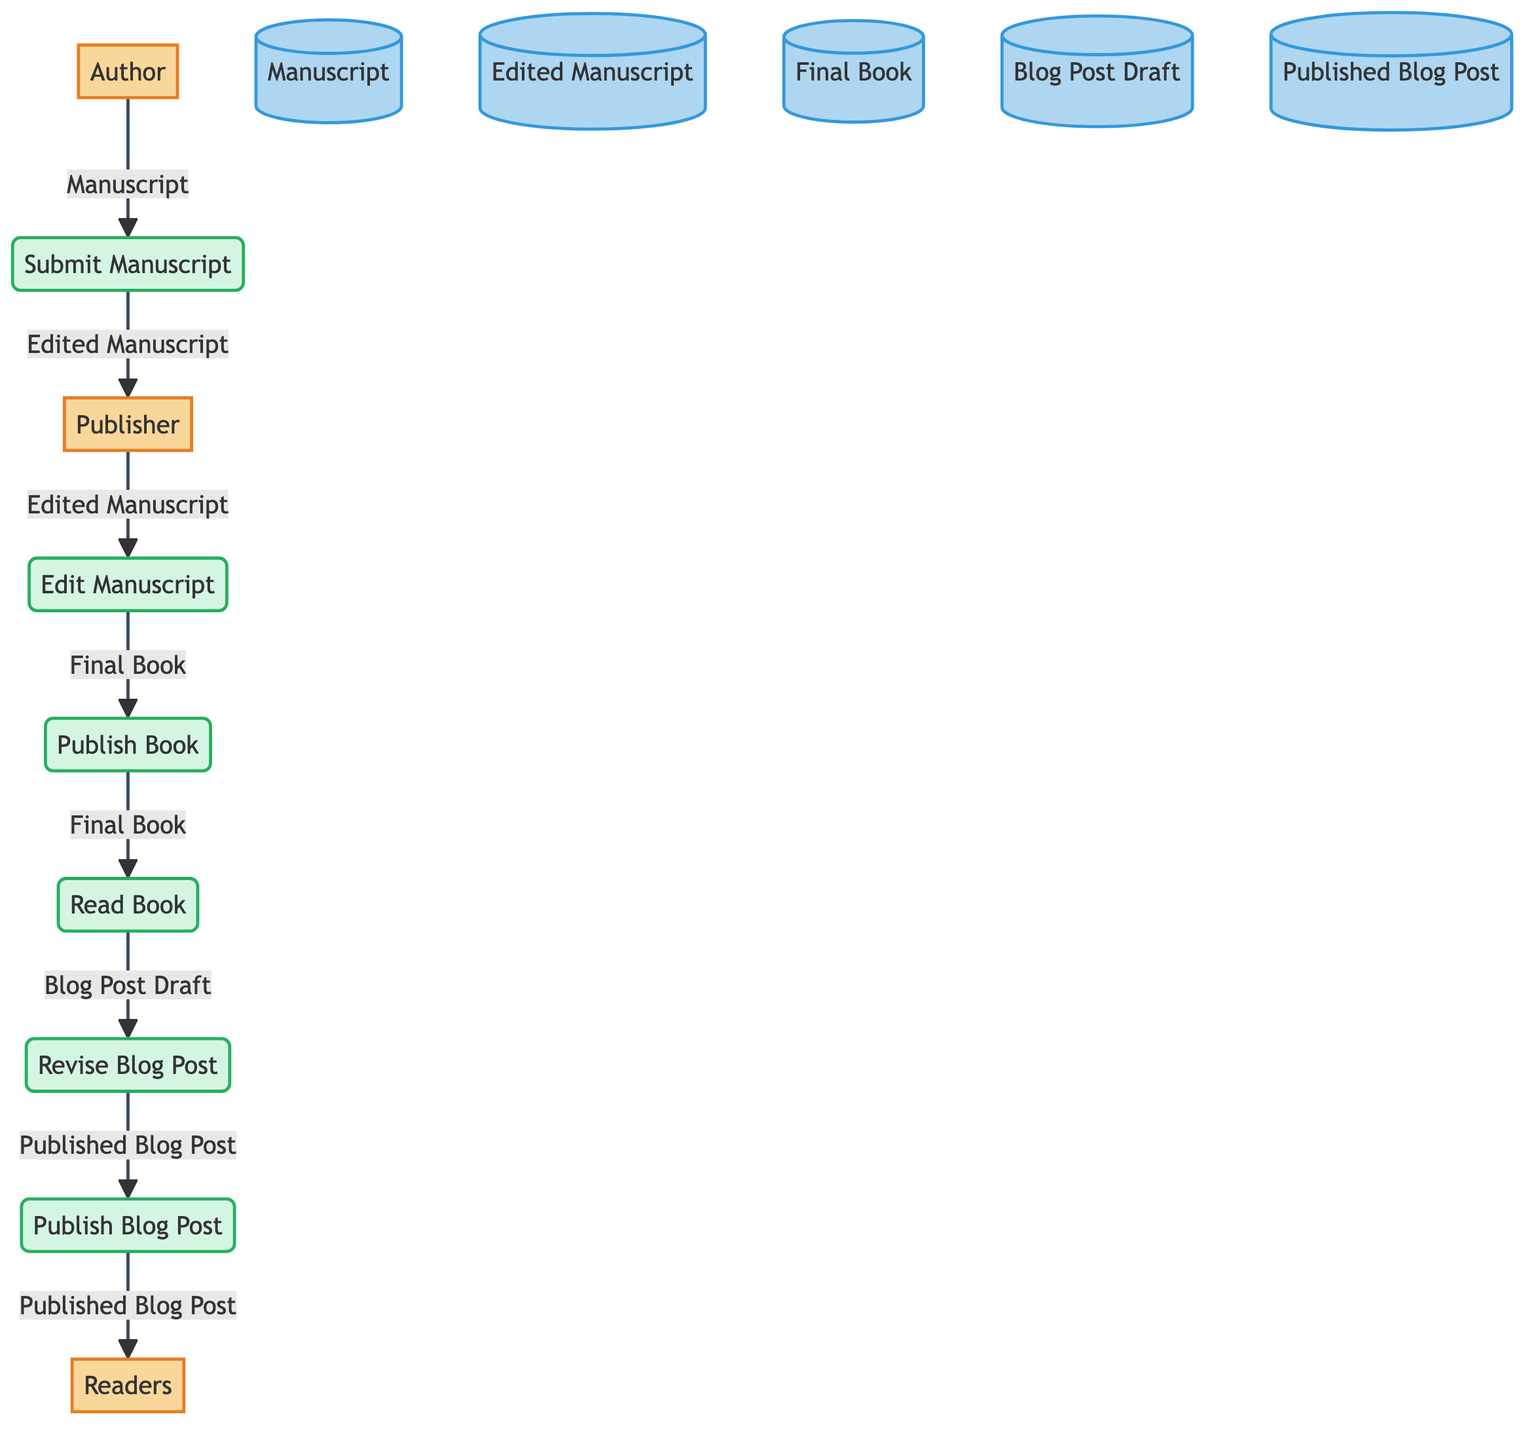What is the first external entity in the diagram? The first external entity listed in the diagram is "Author." This can be found at the top of the diagram where the external entities are depicted.
Answer: Author How many data stores are present in the diagram? The diagram contains six data stores, which include Manuscript, Edited Manuscript, Final Book, Blog Post Draft, and Published Blog Post. By counting each labeled data store in the diagram, we determine the total.
Answer: Six What is the output of the "Edit Manuscript" process? The output of the "Edit Manuscript" process is "Final Book." This is found directly below the process label in the flowchart where the output is specified.
Answer: Final Book Who receives the "Edited Manuscript" from the "Submit Manuscript" process? The "Edited Manuscript" is sent to the "Publisher" from the "Submit Manuscript" process. This flow is indicated by the arrow connecting these two elements in the diagram.
Answer: Publisher How many processes are involved in the blog post creation after reading the book? There are two processes involved in the blog post creation after reading the book: "Revise Blog Post" and "Publish Blog Post." Both processes are sequential steps following the "Read Book" process.
Answer: Two What is the relationship between "Blog Post Draft" and "Published Blog Post"? The "Blog Post Draft" is revised into the "Published Blog Post." This relationship is established through the "Revise Blog Post" process that connects these two data stores.
Answer: Revised What is the final action performed by the "Publish Blog Post" process? The final action performed by the "Publish Blog Post" process is to publish the "Published Blog Post," which is accessible to readers. This is the concluding flow illustrated in the diagram.
Answer: Publish Blog Post Which process sends data to the "Read Book" data store? The "Publish Book" process sends data to the "Read Book" data store. This flow is represented by the arrow leading from "Publish Book" to "Read Book."
Answer: Publish Book What is the flow direction of data from "Revise Blog Post"? The flow direction of data from "Revise Blog Post" is towards "Publish Blog Post." This is illustrated by the arrow indicating the output of the process flowing into the next step in the diagram.
Answer: Publish Blog Post 